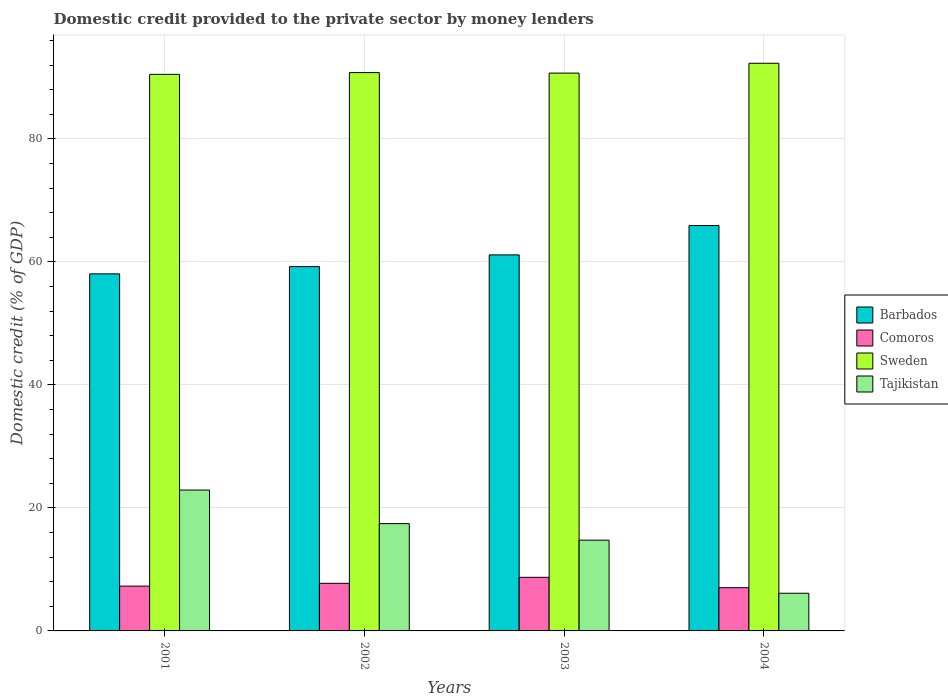Are the number of bars on each tick of the X-axis equal?
Offer a very short reply. Yes. How many bars are there on the 4th tick from the left?
Your response must be concise. 4. How many bars are there on the 4th tick from the right?
Your answer should be compact. 4. In how many cases, is the number of bars for a given year not equal to the number of legend labels?
Offer a very short reply. 0. What is the domestic credit provided to the private sector by money lenders in Sweden in 2004?
Give a very brief answer. 92.32. Across all years, what is the maximum domestic credit provided to the private sector by money lenders in Comoros?
Offer a very short reply. 8.72. Across all years, what is the minimum domestic credit provided to the private sector by money lenders in Sweden?
Your answer should be compact. 90.51. What is the total domestic credit provided to the private sector by money lenders in Barbados in the graph?
Provide a short and direct response. 244.4. What is the difference between the domestic credit provided to the private sector by money lenders in Comoros in 2001 and that in 2002?
Ensure brevity in your answer.  -0.45. What is the difference between the domestic credit provided to the private sector by money lenders in Barbados in 2003 and the domestic credit provided to the private sector by money lenders in Tajikistan in 2004?
Ensure brevity in your answer.  55.03. What is the average domestic credit provided to the private sector by money lenders in Barbados per year?
Make the answer very short. 61.1. In the year 2003, what is the difference between the domestic credit provided to the private sector by money lenders in Comoros and domestic credit provided to the private sector by money lenders in Tajikistan?
Make the answer very short. -6.04. In how many years, is the domestic credit provided to the private sector by money lenders in Tajikistan greater than 56 %?
Give a very brief answer. 0. What is the ratio of the domestic credit provided to the private sector by money lenders in Sweden in 2002 to that in 2004?
Keep it short and to the point. 0.98. What is the difference between the highest and the second highest domestic credit provided to the private sector by money lenders in Tajikistan?
Keep it short and to the point. 5.46. What is the difference between the highest and the lowest domestic credit provided to the private sector by money lenders in Sweden?
Keep it short and to the point. 1.81. Is it the case that in every year, the sum of the domestic credit provided to the private sector by money lenders in Tajikistan and domestic credit provided to the private sector by money lenders in Sweden is greater than the domestic credit provided to the private sector by money lenders in Comoros?
Provide a succinct answer. Yes. How many bars are there?
Keep it short and to the point. 16. Are all the bars in the graph horizontal?
Provide a succinct answer. No. Does the graph contain grids?
Ensure brevity in your answer.  Yes. Where does the legend appear in the graph?
Provide a short and direct response. Center right. How many legend labels are there?
Give a very brief answer. 4. How are the legend labels stacked?
Your response must be concise. Vertical. What is the title of the graph?
Make the answer very short. Domestic credit provided to the private sector by money lenders. Does "Northern Mariana Islands" appear as one of the legend labels in the graph?
Keep it short and to the point. No. What is the label or title of the Y-axis?
Give a very brief answer. Domestic credit (% of GDP). What is the Domestic credit (% of GDP) in Barbados in 2001?
Your answer should be very brief. 58.07. What is the Domestic credit (% of GDP) in Comoros in 2001?
Your response must be concise. 7.29. What is the Domestic credit (% of GDP) of Sweden in 2001?
Make the answer very short. 90.51. What is the Domestic credit (% of GDP) in Tajikistan in 2001?
Provide a short and direct response. 22.91. What is the Domestic credit (% of GDP) in Barbados in 2002?
Provide a succinct answer. 59.25. What is the Domestic credit (% of GDP) in Comoros in 2002?
Your answer should be very brief. 7.74. What is the Domestic credit (% of GDP) of Sweden in 2002?
Give a very brief answer. 90.8. What is the Domestic credit (% of GDP) in Tajikistan in 2002?
Your response must be concise. 17.45. What is the Domestic credit (% of GDP) in Barbados in 2003?
Offer a very short reply. 61.15. What is the Domestic credit (% of GDP) in Comoros in 2003?
Your answer should be very brief. 8.72. What is the Domestic credit (% of GDP) in Sweden in 2003?
Make the answer very short. 90.72. What is the Domestic credit (% of GDP) of Tajikistan in 2003?
Ensure brevity in your answer.  14.76. What is the Domestic credit (% of GDP) of Barbados in 2004?
Make the answer very short. 65.93. What is the Domestic credit (% of GDP) of Comoros in 2004?
Offer a very short reply. 7.03. What is the Domestic credit (% of GDP) of Sweden in 2004?
Offer a very short reply. 92.32. What is the Domestic credit (% of GDP) of Tajikistan in 2004?
Provide a succinct answer. 6.13. Across all years, what is the maximum Domestic credit (% of GDP) in Barbados?
Your answer should be very brief. 65.93. Across all years, what is the maximum Domestic credit (% of GDP) of Comoros?
Your response must be concise. 8.72. Across all years, what is the maximum Domestic credit (% of GDP) of Sweden?
Ensure brevity in your answer.  92.32. Across all years, what is the maximum Domestic credit (% of GDP) in Tajikistan?
Give a very brief answer. 22.91. Across all years, what is the minimum Domestic credit (% of GDP) in Barbados?
Give a very brief answer. 58.07. Across all years, what is the minimum Domestic credit (% of GDP) in Comoros?
Your answer should be very brief. 7.03. Across all years, what is the minimum Domestic credit (% of GDP) in Sweden?
Ensure brevity in your answer.  90.51. Across all years, what is the minimum Domestic credit (% of GDP) of Tajikistan?
Give a very brief answer. 6.13. What is the total Domestic credit (% of GDP) of Barbados in the graph?
Ensure brevity in your answer.  244.4. What is the total Domestic credit (% of GDP) in Comoros in the graph?
Provide a short and direct response. 30.77. What is the total Domestic credit (% of GDP) of Sweden in the graph?
Give a very brief answer. 364.34. What is the total Domestic credit (% of GDP) in Tajikistan in the graph?
Ensure brevity in your answer.  61.25. What is the difference between the Domestic credit (% of GDP) in Barbados in 2001 and that in 2002?
Keep it short and to the point. -1.18. What is the difference between the Domestic credit (% of GDP) of Comoros in 2001 and that in 2002?
Keep it short and to the point. -0.45. What is the difference between the Domestic credit (% of GDP) in Sweden in 2001 and that in 2002?
Your response must be concise. -0.29. What is the difference between the Domestic credit (% of GDP) of Tajikistan in 2001 and that in 2002?
Your answer should be very brief. 5.46. What is the difference between the Domestic credit (% of GDP) in Barbados in 2001 and that in 2003?
Ensure brevity in your answer.  -3.08. What is the difference between the Domestic credit (% of GDP) in Comoros in 2001 and that in 2003?
Your answer should be compact. -1.43. What is the difference between the Domestic credit (% of GDP) in Sweden in 2001 and that in 2003?
Give a very brief answer. -0.21. What is the difference between the Domestic credit (% of GDP) in Tajikistan in 2001 and that in 2003?
Offer a terse response. 8.15. What is the difference between the Domestic credit (% of GDP) of Barbados in 2001 and that in 2004?
Give a very brief answer. -7.86. What is the difference between the Domestic credit (% of GDP) in Comoros in 2001 and that in 2004?
Offer a terse response. 0.26. What is the difference between the Domestic credit (% of GDP) of Sweden in 2001 and that in 2004?
Give a very brief answer. -1.81. What is the difference between the Domestic credit (% of GDP) of Tajikistan in 2001 and that in 2004?
Your response must be concise. 16.78. What is the difference between the Domestic credit (% of GDP) in Barbados in 2002 and that in 2003?
Offer a very short reply. -1.91. What is the difference between the Domestic credit (% of GDP) of Comoros in 2002 and that in 2003?
Ensure brevity in your answer.  -0.98. What is the difference between the Domestic credit (% of GDP) of Sweden in 2002 and that in 2003?
Provide a succinct answer. 0.08. What is the difference between the Domestic credit (% of GDP) in Tajikistan in 2002 and that in 2003?
Ensure brevity in your answer.  2.69. What is the difference between the Domestic credit (% of GDP) in Barbados in 2002 and that in 2004?
Your answer should be very brief. -6.68. What is the difference between the Domestic credit (% of GDP) of Comoros in 2002 and that in 2004?
Offer a terse response. 0.71. What is the difference between the Domestic credit (% of GDP) of Sweden in 2002 and that in 2004?
Make the answer very short. -1.52. What is the difference between the Domestic credit (% of GDP) in Tajikistan in 2002 and that in 2004?
Your answer should be very brief. 11.32. What is the difference between the Domestic credit (% of GDP) of Barbados in 2003 and that in 2004?
Make the answer very short. -4.77. What is the difference between the Domestic credit (% of GDP) in Comoros in 2003 and that in 2004?
Offer a terse response. 1.69. What is the difference between the Domestic credit (% of GDP) of Sweden in 2003 and that in 2004?
Keep it short and to the point. -1.6. What is the difference between the Domestic credit (% of GDP) in Tajikistan in 2003 and that in 2004?
Keep it short and to the point. 8.64. What is the difference between the Domestic credit (% of GDP) in Barbados in 2001 and the Domestic credit (% of GDP) in Comoros in 2002?
Offer a terse response. 50.33. What is the difference between the Domestic credit (% of GDP) in Barbados in 2001 and the Domestic credit (% of GDP) in Sweden in 2002?
Ensure brevity in your answer.  -32.73. What is the difference between the Domestic credit (% of GDP) of Barbados in 2001 and the Domestic credit (% of GDP) of Tajikistan in 2002?
Provide a short and direct response. 40.62. What is the difference between the Domestic credit (% of GDP) in Comoros in 2001 and the Domestic credit (% of GDP) in Sweden in 2002?
Offer a very short reply. -83.51. What is the difference between the Domestic credit (% of GDP) in Comoros in 2001 and the Domestic credit (% of GDP) in Tajikistan in 2002?
Provide a short and direct response. -10.16. What is the difference between the Domestic credit (% of GDP) of Sweden in 2001 and the Domestic credit (% of GDP) of Tajikistan in 2002?
Provide a succinct answer. 73.06. What is the difference between the Domestic credit (% of GDP) of Barbados in 2001 and the Domestic credit (% of GDP) of Comoros in 2003?
Keep it short and to the point. 49.35. What is the difference between the Domestic credit (% of GDP) in Barbados in 2001 and the Domestic credit (% of GDP) in Sweden in 2003?
Your answer should be very brief. -32.65. What is the difference between the Domestic credit (% of GDP) in Barbados in 2001 and the Domestic credit (% of GDP) in Tajikistan in 2003?
Your response must be concise. 43.31. What is the difference between the Domestic credit (% of GDP) in Comoros in 2001 and the Domestic credit (% of GDP) in Sweden in 2003?
Keep it short and to the point. -83.43. What is the difference between the Domestic credit (% of GDP) of Comoros in 2001 and the Domestic credit (% of GDP) of Tajikistan in 2003?
Make the answer very short. -7.48. What is the difference between the Domestic credit (% of GDP) of Sweden in 2001 and the Domestic credit (% of GDP) of Tajikistan in 2003?
Provide a succinct answer. 75.75. What is the difference between the Domestic credit (% of GDP) in Barbados in 2001 and the Domestic credit (% of GDP) in Comoros in 2004?
Offer a very short reply. 51.04. What is the difference between the Domestic credit (% of GDP) of Barbados in 2001 and the Domestic credit (% of GDP) of Sweden in 2004?
Make the answer very short. -34.25. What is the difference between the Domestic credit (% of GDP) of Barbados in 2001 and the Domestic credit (% of GDP) of Tajikistan in 2004?
Provide a succinct answer. 51.94. What is the difference between the Domestic credit (% of GDP) of Comoros in 2001 and the Domestic credit (% of GDP) of Sweden in 2004?
Ensure brevity in your answer.  -85.03. What is the difference between the Domestic credit (% of GDP) in Comoros in 2001 and the Domestic credit (% of GDP) in Tajikistan in 2004?
Offer a very short reply. 1.16. What is the difference between the Domestic credit (% of GDP) of Sweden in 2001 and the Domestic credit (% of GDP) of Tajikistan in 2004?
Offer a very short reply. 84.38. What is the difference between the Domestic credit (% of GDP) of Barbados in 2002 and the Domestic credit (% of GDP) of Comoros in 2003?
Provide a short and direct response. 50.53. What is the difference between the Domestic credit (% of GDP) of Barbados in 2002 and the Domestic credit (% of GDP) of Sweden in 2003?
Make the answer very short. -31.47. What is the difference between the Domestic credit (% of GDP) of Barbados in 2002 and the Domestic credit (% of GDP) of Tajikistan in 2003?
Your answer should be very brief. 44.49. What is the difference between the Domestic credit (% of GDP) of Comoros in 2002 and the Domestic credit (% of GDP) of Sweden in 2003?
Keep it short and to the point. -82.98. What is the difference between the Domestic credit (% of GDP) of Comoros in 2002 and the Domestic credit (% of GDP) of Tajikistan in 2003?
Provide a short and direct response. -7.02. What is the difference between the Domestic credit (% of GDP) of Sweden in 2002 and the Domestic credit (% of GDP) of Tajikistan in 2003?
Offer a very short reply. 76.04. What is the difference between the Domestic credit (% of GDP) of Barbados in 2002 and the Domestic credit (% of GDP) of Comoros in 2004?
Keep it short and to the point. 52.22. What is the difference between the Domestic credit (% of GDP) in Barbados in 2002 and the Domestic credit (% of GDP) in Sweden in 2004?
Provide a succinct answer. -33.07. What is the difference between the Domestic credit (% of GDP) in Barbados in 2002 and the Domestic credit (% of GDP) in Tajikistan in 2004?
Make the answer very short. 53.12. What is the difference between the Domestic credit (% of GDP) in Comoros in 2002 and the Domestic credit (% of GDP) in Sweden in 2004?
Your answer should be very brief. -84.58. What is the difference between the Domestic credit (% of GDP) of Comoros in 2002 and the Domestic credit (% of GDP) of Tajikistan in 2004?
Offer a terse response. 1.61. What is the difference between the Domestic credit (% of GDP) of Sweden in 2002 and the Domestic credit (% of GDP) of Tajikistan in 2004?
Offer a terse response. 84.67. What is the difference between the Domestic credit (% of GDP) in Barbados in 2003 and the Domestic credit (% of GDP) in Comoros in 2004?
Provide a succinct answer. 54.12. What is the difference between the Domestic credit (% of GDP) in Barbados in 2003 and the Domestic credit (% of GDP) in Sweden in 2004?
Provide a succinct answer. -31.16. What is the difference between the Domestic credit (% of GDP) in Barbados in 2003 and the Domestic credit (% of GDP) in Tajikistan in 2004?
Your response must be concise. 55.03. What is the difference between the Domestic credit (% of GDP) of Comoros in 2003 and the Domestic credit (% of GDP) of Sweden in 2004?
Ensure brevity in your answer.  -83.6. What is the difference between the Domestic credit (% of GDP) of Comoros in 2003 and the Domestic credit (% of GDP) of Tajikistan in 2004?
Your answer should be compact. 2.59. What is the difference between the Domestic credit (% of GDP) in Sweden in 2003 and the Domestic credit (% of GDP) in Tajikistan in 2004?
Offer a terse response. 84.59. What is the average Domestic credit (% of GDP) in Barbados per year?
Keep it short and to the point. 61.1. What is the average Domestic credit (% of GDP) of Comoros per year?
Keep it short and to the point. 7.69. What is the average Domestic credit (% of GDP) of Sweden per year?
Ensure brevity in your answer.  91.09. What is the average Domestic credit (% of GDP) of Tajikistan per year?
Your response must be concise. 15.31. In the year 2001, what is the difference between the Domestic credit (% of GDP) in Barbados and Domestic credit (% of GDP) in Comoros?
Offer a very short reply. 50.78. In the year 2001, what is the difference between the Domestic credit (% of GDP) of Barbados and Domestic credit (% of GDP) of Sweden?
Your response must be concise. -32.44. In the year 2001, what is the difference between the Domestic credit (% of GDP) in Barbados and Domestic credit (% of GDP) in Tajikistan?
Give a very brief answer. 35.16. In the year 2001, what is the difference between the Domestic credit (% of GDP) in Comoros and Domestic credit (% of GDP) in Sweden?
Your answer should be compact. -83.22. In the year 2001, what is the difference between the Domestic credit (% of GDP) in Comoros and Domestic credit (% of GDP) in Tajikistan?
Offer a very short reply. -15.62. In the year 2001, what is the difference between the Domestic credit (% of GDP) in Sweden and Domestic credit (% of GDP) in Tajikistan?
Offer a very short reply. 67.6. In the year 2002, what is the difference between the Domestic credit (% of GDP) in Barbados and Domestic credit (% of GDP) in Comoros?
Offer a terse response. 51.51. In the year 2002, what is the difference between the Domestic credit (% of GDP) of Barbados and Domestic credit (% of GDP) of Sweden?
Make the answer very short. -31.55. In the year 2002, what is the difference between the Domestic credit (% of GDP) in Barbados and Domestic credit (% of GDP) in Tajikistan?
Provide a succinct answer. 41.8. In the year 2002, what is the difference between the Domestic credit (% of GDP) of Comoros and Domestic credit (% of GDP) of Sweden?
Your answer should be compact. -83.06. In the year 2002, what is the difference between the Domestic credit (% of GDP) of Comoros and Domestic credit (% of GDP) of Tajikistan?
Ensure brevity in your answer.  -9.71. In the year 2002, what is the difference between the Domestic credit (% of GDP) of Sweden and Domestic credit (% of GDP) of Tajikistan?
Your answer should be very brief. 73.35. In the year 2003, what is the difference between the Domestic credit (% of GDP) in Barbados and Domestic credit (% of GDP) in Comoros?
Ensure brevity in your answer.  52.44. In the year 2003, what is the difference between the Domestic credit (% of GDP) in Barbados and Domestic credit (% of GDP) in Sweden?
Offer a very short reply. -29.56. In the year 2003, what is the difference between the Domestic credit (% of GDP) in Barbados and Domestic credit (% of GDP) in Tajikistan?
Your answer should be compact. 46.39. In the year 2003, what is the difference between the Domestic credit (% of GDP) of Comoros and Domestic credit (% of GDP) of Sweden?
Your answer should be very brief. -82. In the year 2003, what is the difference between the Domestic credit (% of GDP) in Comoros and Domestic credit (% of GDP) in Tajikistan?
Offer a very short reply. -6.04. In the year 2003, what is the difference between the Domestic credit (% of GDP) of Sweden and Domestic credit (% of GDP) of Tajikistan?
Keep it short and to the point. 75.95. In the year 2004, what is the difference between the Domestic credit (% of GDP) in Barbados and Domestic credit (% of GDP) in Comoros?
Keep it short and to the point. 58.9. In the year 2004, what is the difference between the Domestic credit (% of GDP) of Barbados and Domestic credit (% of GDP) of Sweden?
Your answer should be compact. -26.39. In the year 2004, what is the difference between the Domestic credit (% of GDP) in Barbados and Domestic credit (% of GDP) in Tajikistan?
Your response must be concise. 59.8. In the year 2004, what is the difference between the Domestic credit (% of GDP) in Comoros and Domestic credit (% of GDP) in Sweden?
Offer a very short reply. -85.29. In the year 2004, what is the difference between the Domestic credit (% of GDP) of Comoros and Domestic credit (% of GDP) of Tajikistan?
Ensure brevity in your answer.  0.9. In the year 2004, what is the difference between the Domestic credit (% of GDP) of Sweden and Domestic credit (% of GDP) of Tajikistan?
Provide a short and direct response. 86.19. What is the ratio of the Domestic credit (% of GDP) in Barbados in 2001 to that in 2002?
Your answer should be compact. 0.98. What is the ratio of the Domestic credit (% of GDP) of Comoros in 2001 to that in 2002?
Provide a succinct answer. 0.94. What is the ratio of the Domestic credit (% of GDP) of Sweden in 2001 to that in 2002?
Your answer should be very brief. 1. What is the ratio of the Domestic credit (% of GDP) in Tajikistan in 2001 to that in 2002?
Give a very brief answer. 1.31. What is the ratio of the Domestic credit (% of GDP) in Barbados in 2001 to that in 2003?
Give a very brief answer. 0.95. What is the ratio of the Domestic credit (% of GDP) in Comoros in 2001 to that in 2003?
Offer a terse response. 0.84. What is the ratio of the Domestic credit (% of GDP) in Tajikistan in 2001 to that in 2003?
Offer a terse response. 1.55. What is the ratio of the Domestic credit (% of GDP) in Barbados in 2001 to that in 2004?
Give a very brief answer. 0.88. What is the ratio of the Domestic credit (% of GDP) of Comoros in 2001 to that in 2004?
Offer a terse response. 1.04. What is the ratio of the Domestic credit (% of GDP) in Sweden in 2001 to that in 2004?
Provide a short and direct response. 0.98. What is the ratio of the Domestic credit (% of GDP) in Tajikistan in 2001 to that in 2004?
Ensure brevity in your answer.  3.74. What is the ratio of the Domestic credit (% of GDP) in Barbados in 2002 to that in 2003?
Offer a very short reply. 0.97. What is the ratio of the Domestic credit (% of GDP) of Comoros in 2002 to that in 2003?
Provide a short and direct response. 0.89. What is the ratio of the Domestic credit (% of GDP) of Tajikistan in 2002 to that in 2003?
Ensure brevity in your answer.  1.18. What is the ratio of the Domestic credit (% of GDP) in Barbados in 2002 to that in 2004?
Keep it short and to the point. 0.9. What is the ratio of the Domestic credit (% of GDP) of Comoros in 2002 to that in 2004?
Give a very brief answer. 1.1. What is the ratio of the Domestic credit (% of GDP) in Sweden in 2002 to that in 2004?
Provide a short and direct response. 0.98. What is the ratio of the Domestic credit (% of GDP) of Tajikistan in 2002 to that in 2004?
Your answer should be compact. 2.85. What is the ratio of the Domestic credit (% of GDP) in Barbados in 2003 to that in 2004?
Ensure brevity in your answer.  0.93. What is the ratio of the Domestic credit (% of GDP) in Comoros in 2003 to that in 2004?
Offer a very short reply. 1.24. What is the ratio of the Domestic credit (% of GDP) of Sweden in 2003 to that in 2004?
Offer a very short reply. 0.98. What is the ratio of the Domestic credit (% of GDP) in Tajikistan in 2003 to that in 2004?
Make the answer very short. 2.41. What is the difference between the highest and the second highest Domestic credit (% of GDP) of Barbados?
Your response must be concise. 4.77. What is the difference between the highest and the second highest Domestic credit (% of GDP) in Comoros?
Ensure brevity in your answer.  0.98. What is the difference between the highest and the second highest Domestic credit (% of GDP) of Sweden?
Your answer should be very brief. 1.52. What is the difference between the highest and the second highest Domestic credit (% of GDP) in Tajikistan?
Provide a succinct answer. 5.46. What is the difference between the highest and the lowest Domestic credit (% of GDP) of Barbados?
Make the answer very short. 7.86. What is the difference between the highest and the lowest Domestic credit (% of GDP) in Comoros?
Keep it short and to the point. 1.69. What is the difference between the highest and the lowest Domestic credit (% of GDP) of Sweden?
Your response must be concise. 1.81. What is the difference between the highest and the lowest Domestic credit (% of GDP) in Tajikistan?
Provide a short and direct response. 16.78. 